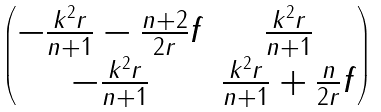<formula> <loc_0><loc_0><loc_500><loc_500>\begin{pmatrix} - \frac { k ^ { 2 } r } { n + 1 } - \frac { n + 2 } { 2 r } f & \frac { k ^ { 2 } r } { n + 1 } \\ - \frac { k ^ { 2 } r } { n + 1 } & \frac { k ^ { 2 } r } { n + 1 } + \frac { n } { 2 r } f \end{pmatrix}</formula> 